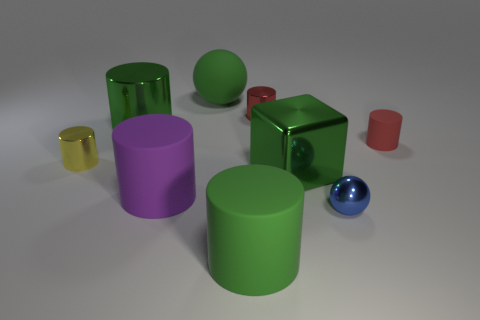Add 1 metal objects. How many objects exist? 10 Subtract all large green cylinders. How many cylinders are left? 4 Subtract all cubes. How many objects are left? 8 Add 1 big green cylinders. How many big green cylinders are left? 3 Add 7 big green metallic objects. How many big green metallic objects exist? 9 Subtract all purple cylinders. How many cylinders are left? 5 Subtract 0 blue cylinders. How many objects are left? 9 Subtract 1 spheres. How many spheres are left? 1 Subtract all brown cubes. Subtract all yellow balls. How many cubes are left? 1 Subtract all red cylinders. How many cyan spheres are left? 0 